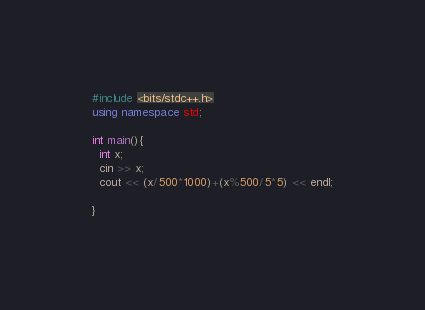<code> <loc_0><loc_0><loc_500><loc_500><_C++_>#include <bits/stdc++.h>
using namespace std;

int main(){
  int x;
  cin >> x;
  cout << (x/500*1000)+(x%500/5*5) << endl;

}</code> 